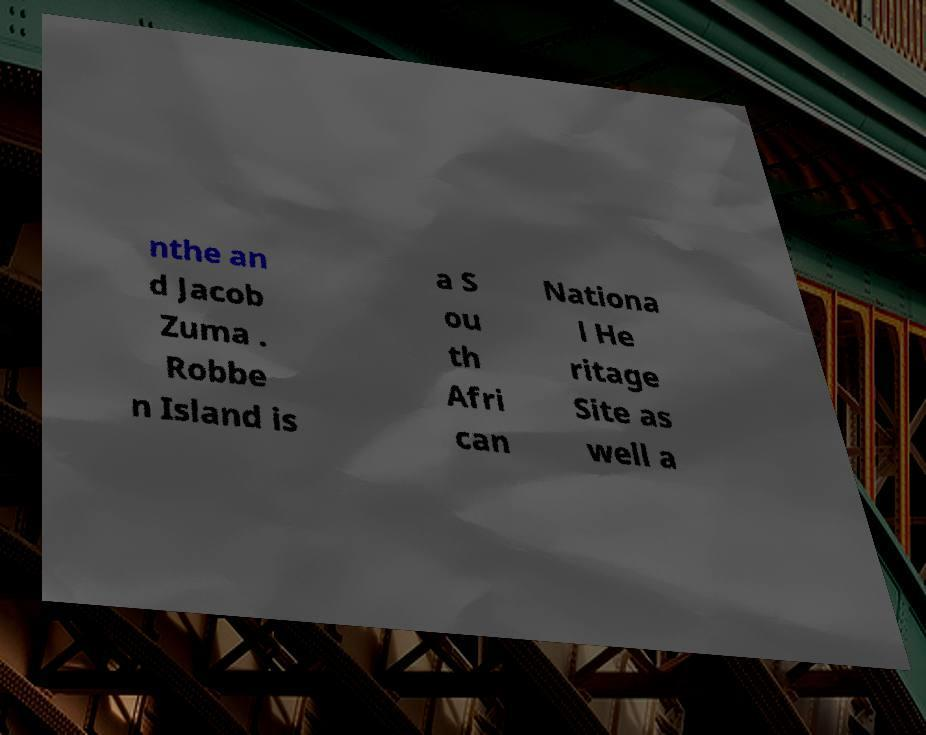Can you read and provide the text displayed in the image?This photo seems to have some interesting text. Can you extract and type it out for me? nthe an d Jacob Zuma . Robbe n Island is a S ou th Afri can Nationa l He ritage Site as well a 